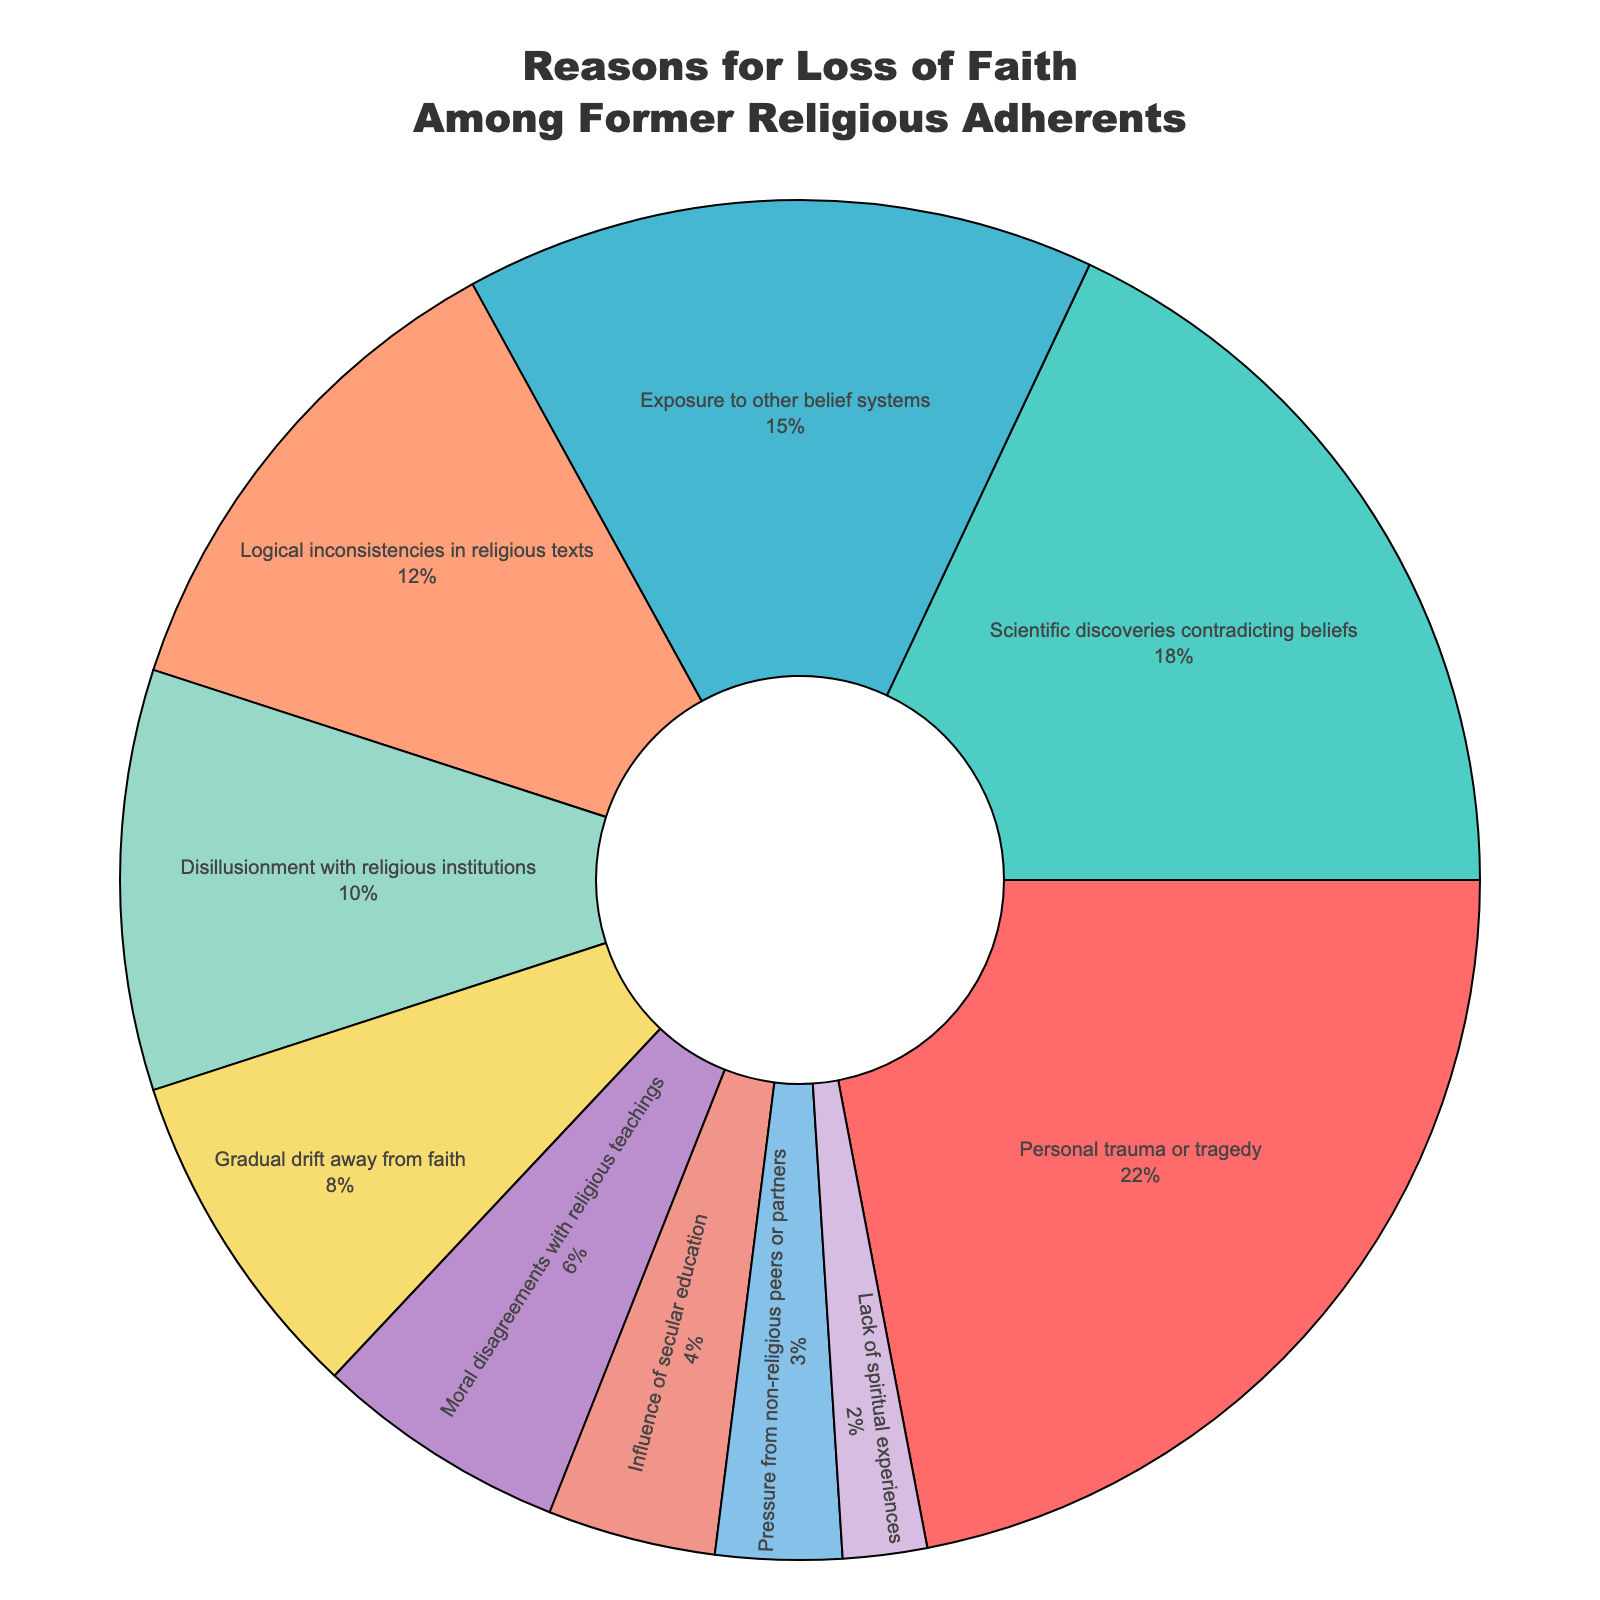What is the most common reason for the loss of faith among former religious adherents? The largest percentage slice in the pie chart is labeled "Personal trauma or tragedy," which has the highest percentage.
Answer: Personal trauma or tragedy Which reason has the lowest percentage for loss of faith? The smallest slice in the pie chart is "Lack of spiritual experiences," which has the lowest percentage.
Answer: Lack of spiritual experiences What is the combined percentage for "Personal trauma or tragedy" and "Scientific discoveries contradicting beliefs"? "Personal trauma or tragedy" is 22% and "Scientific discoveries contradicting beliefs" is 18%. Summing these percentages gives 22% + 18% = 40%.
Answer: 40% How much larger is the percentage for "Personal trauma or tragedy" compared to "Gradual drift away from faith"? "Personal trauma or tragedy" is 22% and "Gradual drift away from faith" is 8%. The difference is 22% - 8% = 14%.
Answer: 14% Which two reasons together represent a quarter of the respondents? "Logical inconsistencies in religious texts" and "Disillusionment with religious institutions" together add up to 12% + 10% = 22%. "Exposure to other belief systems" and "Gradual drift away from faith" together add up to 15% + 8% = 23%. Neither equals exactly 25%, but "Scientific discoveries contradicting beliefs" and "Gradual drift away from faith" together add up to 18% + 8% = 26%, which is close.
Answer: Scientific discoveries contradicting beliefs and Gradual drift away from faith Which color represents "Influence of secular education"? The color associated with "Influence of secular education" in the pie chart is visually identifiable as a light blue color.
Answer: Light blue Are the percentages for "Moral disagreements with religious teachings" and "Exposure to other belief systems" different, and if so, by how much? "Moral disagreements with religious teachings" is 6% and "Exposure to other belief systems" is 15%. The difference is 15% - 6% = 9%.
Answer: 9% What is the collective percentage of reasons related to societal and interpersonal influence ("Disillusionment with religious institutions", "Influence of secular education", "Pressure from non-religious peers or partners")? Adding up the percentages for "Disillusionment with religious institutions" (10%), "Influence of secular education" (4%), and "Pressure from non-religious peers or partners" (3%) gives 10% + 4% + 3% = 17%.
Answer: 17% Does any reason account for more than one-fifth of the total? Yes, "Personal trauma or tragedy" is 22%, which is more than one-fifth (20%) of the total respondents.
Answer: Yes 